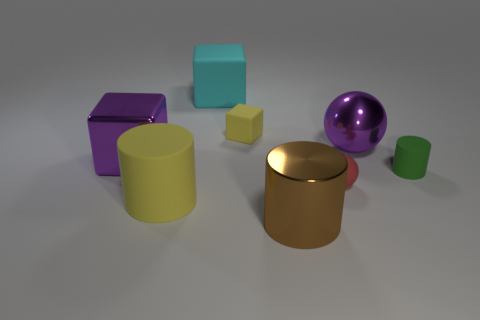Is the small sphere the same color as the tiny rubber cylinder?
Your answer should be compact. No. Is the number of tiny matte spheres less than the number of small gray rubber balls?
Give a very brief answer. No. How many other objects are the same color as the metallic cube?
Your answer should be very brief. 1. How many spheres are there?
Offer a terse response. 2. Are there fewer large brown shiny cylinders left of the metal block than cyan rubber blocks?
Provide a short and direct response. Yes. Is the material of the yellow object in front of the red object the same as the tiny yellow cube?
Keep it short and to the point. Yes. The shiny thing to the left of the yellow rubber thing that is in front of the metallic block in front of the big purple shiny ball is what shape?
Ensure brevity in your answer.  Cube. Are there any yellow cubes of the same size as the brown shiny cylinder?
Offer a terse response. No. The green object has what size?
Ensure brevity in your answer.  Small. What number of gray metal blocks have the same size as the cyan object?
Offer a terse response. 0. 